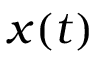<formula> <loc_0><loc_0><loc_500><loc_500>x ( t )</formula> 